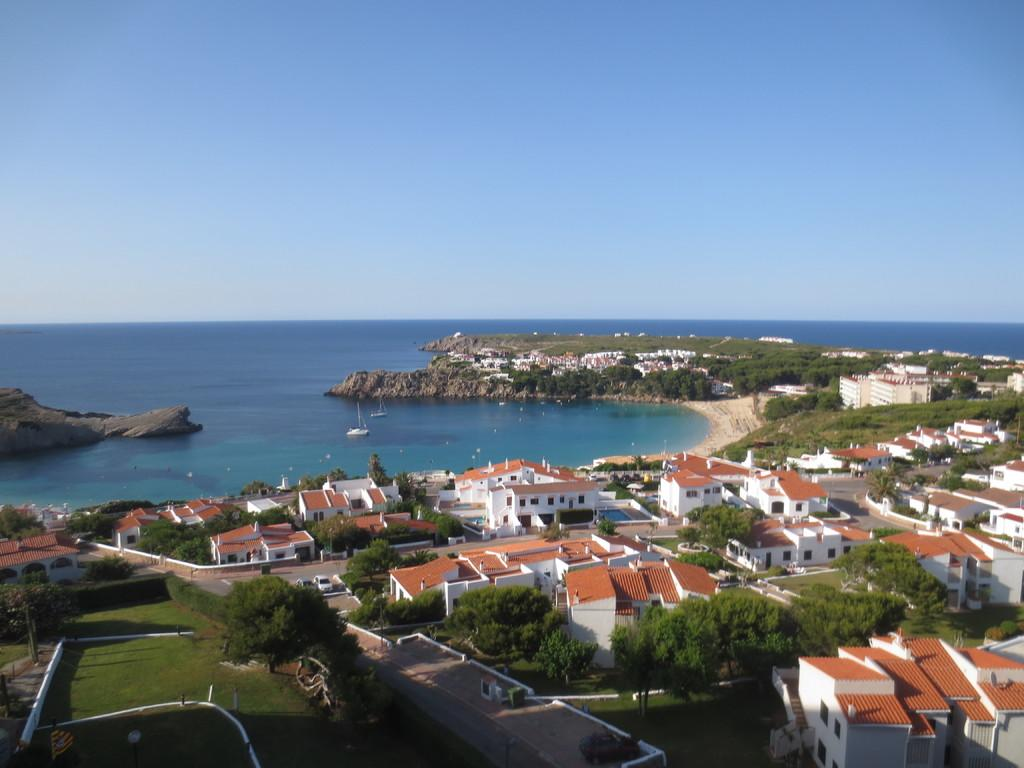What type of view is depicted in the image? The image is an aerial view. What structures can be seen in the image? There are houses in the image. What type of vegetation is present in the image? There are trees in the image. What man-made features are visible in the image? There are roads and vehicles visible in the image. What bodies of water are present in the image? There are boats on the water in the image. What is visible at the top of the image? The sky is visible at the top of the image. How many apples are hanging from the trees in the image? There are no apples visible in the image; only trees are present. What type of base is supporting the houses in the image? The image does not provide information about the base supporting the houses; it only shows the houses themselves. 